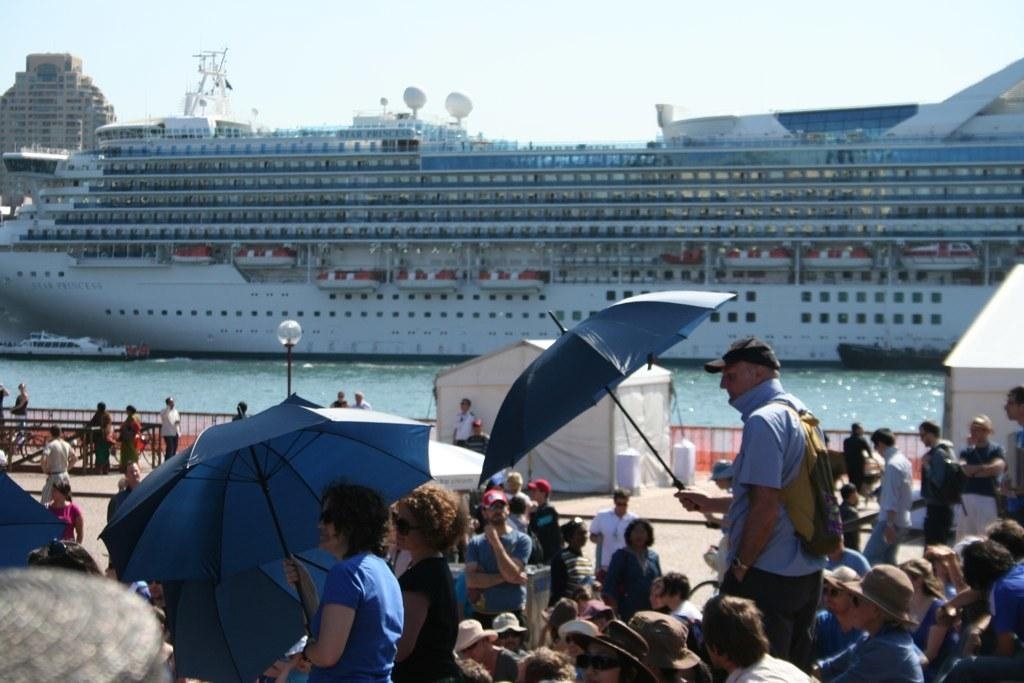How many people can be seen in the image? There are many people in the image. What are some of the people wearing? Some people are wearing caps. What objects can be seen in the image besides people? There is an umbrella, a light pole, a fence, a tent, bicycles, water, a ship, and the sky visible in the image. How does the anger in the image manifest itself? There is no anger present in the image; it is a neutral scene with people, objects, and a ship. Can you describe the sneeze that occurs in the image? There is no sneeze present in the image; it is a still image with no motion or sound. 